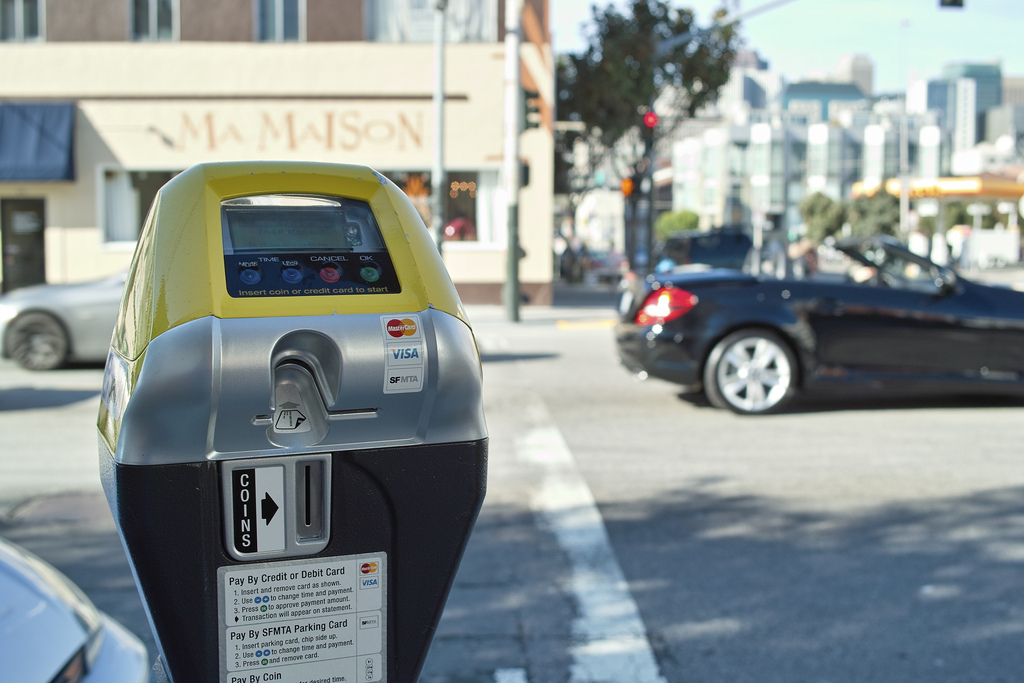Can you describe the ambiance of this location based on the image? The ambiance of this location appears to be a bustling urban street, likely in the midmorning. The presence of vehicles, such as the black convertible and other cars, along with the pedestrians, indicates a lively and active environment. The clear sky and bright sunlight give the scene a vibrant and energetic feel. What kind of businesses might be found in the buildings shown? Considering the urban setting, the buildings likely house a variety of businesses. You might find cafés, small boutiques, restaurants, and professional offices such as law firms or real estate agencies. The presence of a parking meter suggests convenience for short-term visitors typical of mixed-use commercial areas. If this street were part of a historical district, what stories might it tell? If this street were part of a historical district, it might tell stories of a bygone era when horse-drawn carriages roamed the cobblestone roads. The buildings could have witnessed the transformation from early 20th-century shops to modern-day businesses. Tales of local craftsmen, early settlers, and influential figures who frequented these streets could be retold. Perhaps during wartime, the area served as a hub for community efforts, and now it stands as a testament to the city’s resilience and growth. Visualize a futuristic scenario of this street. How might it look? In a futuristic scenario, this street could be transformed into a sleek and advanced urban area. Autonomous electric vehicles glide silently along the road, which might be equipped with smart sensors and holographic traffic signs. The parking meter could be replaced by digital parking pods that wirelessly charge vehicles while parked. The buildings could have energy-efficient facades with dynamic advertisements projected onto them. Vertical gardens and urban farms might cover the exteriors, creating a green, eco-friendly environment. The atmosphere is a blend of high-tech innovation and sustainable living. 